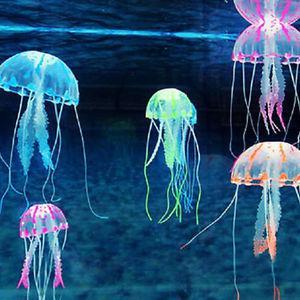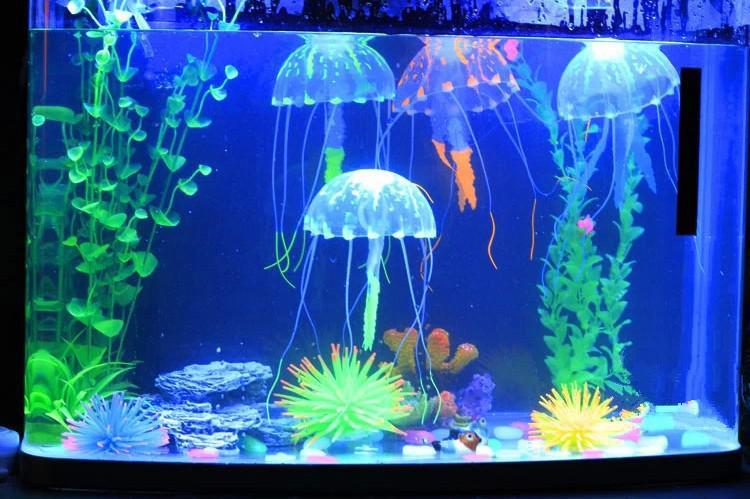The first image is the image on the left, the second image is the image on the right. For the images shown, is this caption "Each image features different colors of jellyfish with long tentacles dangling downward, and the right image features jellyfish in an aquarium tank with green plants." true? Answer yes or no. Yes. The first image is the image on the left, the second image is the image on the right. Assess this claim about the two images: "One image in the pair shows jellyfish of all one color while the other shows jellyfish in a variety of colors.". Correct or not? Answer yes or no. No. 